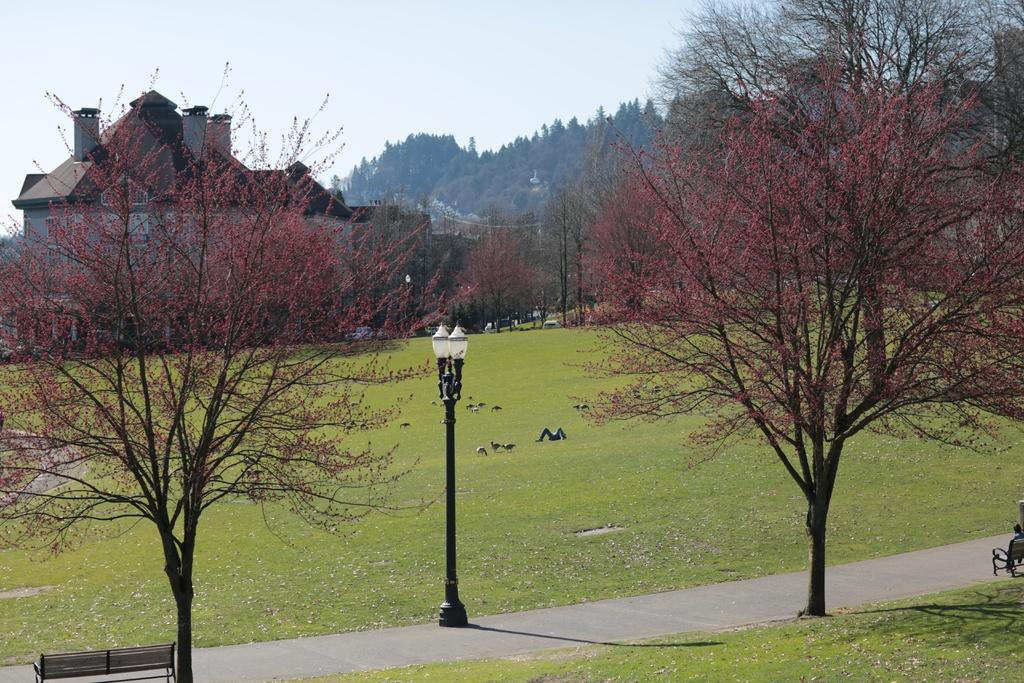What type of structure is present in the image? There is a building in the image. What is another object that can be seen in the image? There is a light pole in the image. What is the primary surface visible in the image? There is a road in the image. What type of seating is available in the image? There are benches in the image. What type of animals are present in the image? There are birds in the image. What type of vegetation is present in the image? There are trees in the image. What is visible at the top of the image? The sky is visible in the image. What type of ground is visible in the image? There is no specific type of ground mentioned or visible in the image; it is simply a road. What type of representative is present in the image? There is no representative present in the image; it features a building, light pole, road, benches, birds, trees, and the sky. 